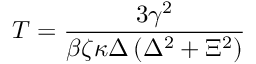<formula> <loc_0><loc_0><loc_500><loc_500>T = \frac { 3 \gamma ^ { 2 } } { \beta \zeta \kappa \Delta \left ( \Delta ^ { 2 } + \Xi ^ { 2 } \right ) }</formula> 